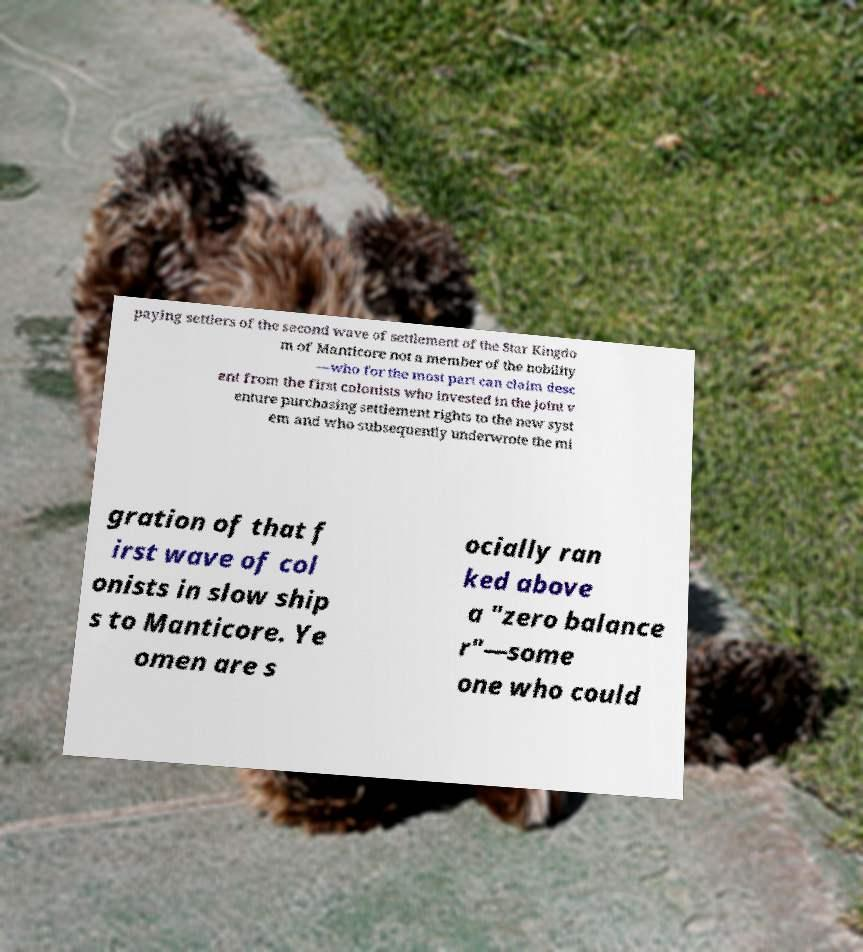There's text embedded in this image that I need extracted. Can you transcribe it verbatim? paying settlers of the second wave of settlement of the Star Kingdo m of Manticore not a member of the nobility —who for the most part can claim desc ent from the first colonists who invested in the joint v enture purchasing settlement rights to the new syst em and who subsequently underwrote the mi gration of that f irst wave of col onists in slow ship s to Manticore. Ye omen are s ocially ran ked above a "zero balance r"—some one who could 